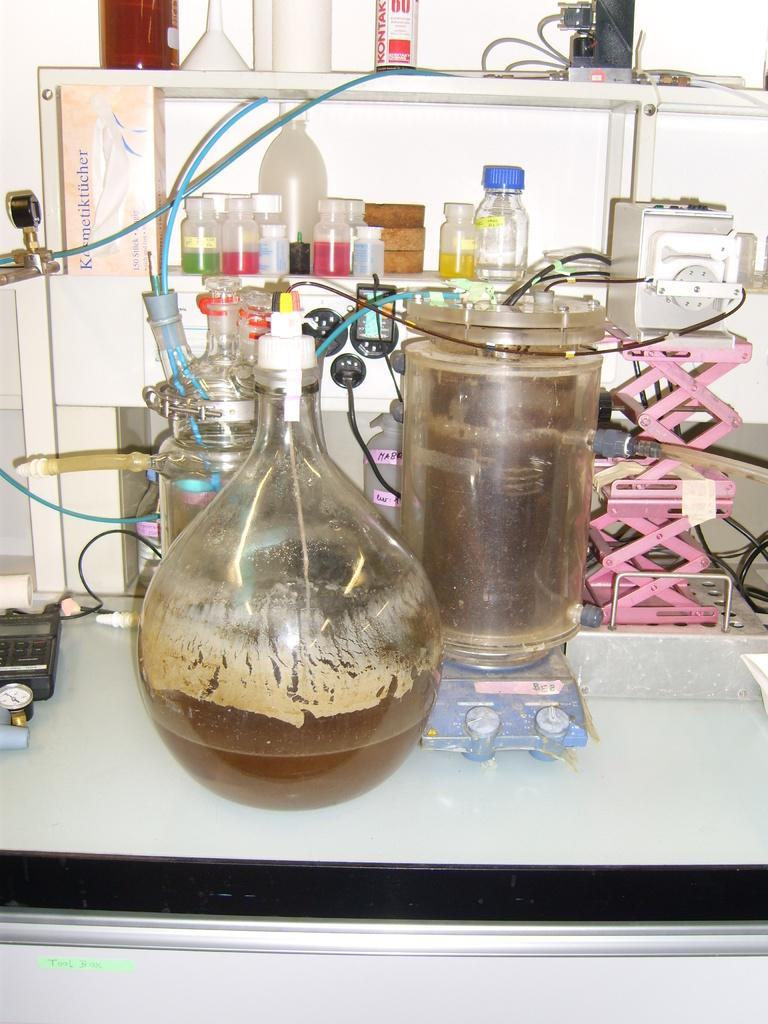What piece of furniture is present in the image? There is a table in the image. What object is placed on the table? There is a bottle on the table. What type of bottles are on the table? There are chemical bottles on the table. What animals can be seen in the zoo in the image? There is no zoo present in the image; it features a table with a bottle and chemical bottles. What type of frame is used for the table in the image? The image does not provide information about the frame of the table, as it only shows the tabletop and objects on it. 